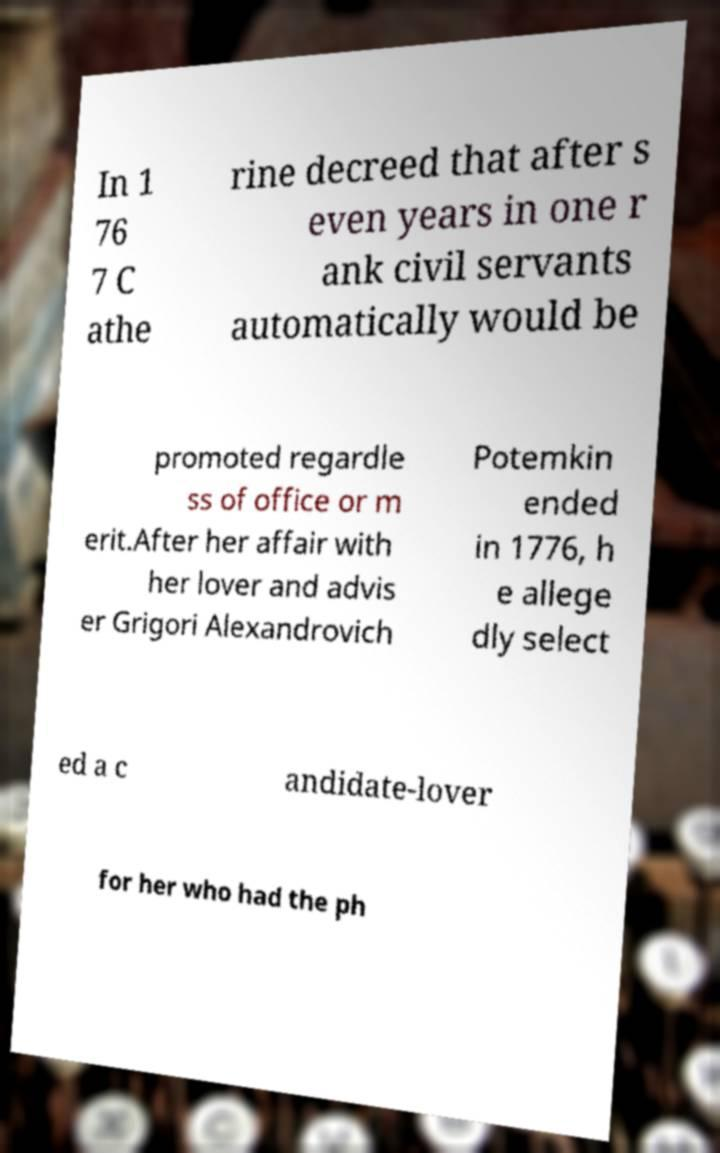Could you assist in decoding the text presented in this image and type it out clearly? In 1 76 7 C athe rine decreed that after s even years in one r ank civil servants automatically would be promoted regardle ss of office or m erit.After her affair with her lover and advis er Grigori Alexandrovich Potemkin ended in 1776, h e allege dly select ed a c andidate-lover for her who had the ph 